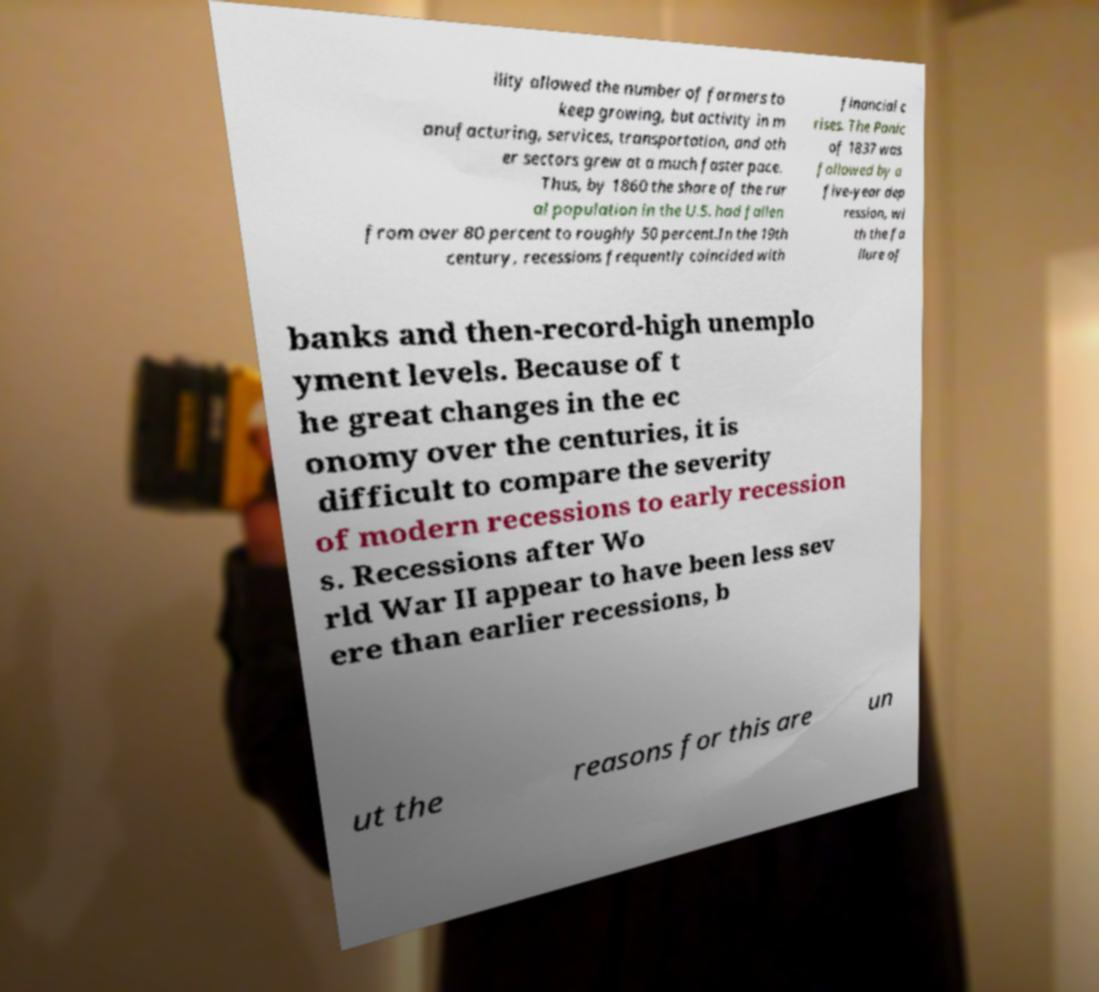Could you extract and type out the text from this image? ility allowed the number of farmers to keep growing, but activity in m anufacturing, services, transportation, and oth er sectors grew at a much faster pace. Thus, by 1860 the share of the rur al population in the U.S. had fallen from over 80 percent to roughly 50 percent.In the 19th century, recessions frequently coincided with financial c rises. The Panic of 1837 was followed by a five-year dep ression, wi th the fa ilure of banks and then-record-high unemplo yment levels. Because of t he great changes in the ec onomy over the centuries, it is difficult to compare the severity of modern recessions to early recession s. Recessions after Wo rld War II appear to have been less sev ere than earlier recessions, b ut the reasons for this are un 